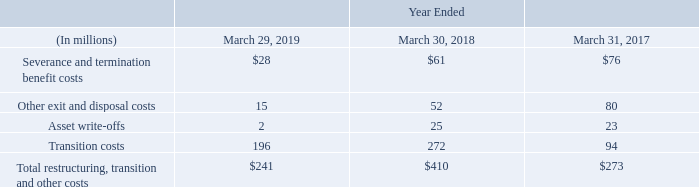Fiscal 2017 Plan
We initiated a restructuring plan in the first quarter of fiscal 2017 to reduce complexity by means of long-term structural improvements (the Fiscal 2017 Plan), under which we reduced headcount and closed certain facilities. These actions were completed in fiscal 2019 at a cumulative cost of $289 million.
Our restructuring, transition and other costs are presented in the table below:
Included in our fiscal 2018 other exit and disposal costs is a $29 million impairment charge related to certain land and buildings previously reported as property and equipment that were reclassified to assets held for sale.
As of March 29, 2019, the restructuring liabilities were not significant.
What does the table represent? Our restructuring, transition and other costs. What is the Severance and termination benefit costs for Year ended March 29,2019?
Answer scale should be: million. $28. What is the Total restructuring, transition and other costs for Year ended March 29,2019?
Answer scale should be: million. $241. What is the Total restructuring, transition and other costs for the fiscal years 2019, 2018, 2017?
Answer scale should be: million. 241+410+273
Answer: 924. What is the average Total restructuring, transition and other costs for the fiscal years 2019, 2018, 2017?
Answer scale should be: million. (241+410+273)/3
Answer: 308. What is the change in Total restructuring, transition and other costs from fiscal 2018 to fiscal 2019?
Answer scale should be: million. 241-410
Answer: -169. 